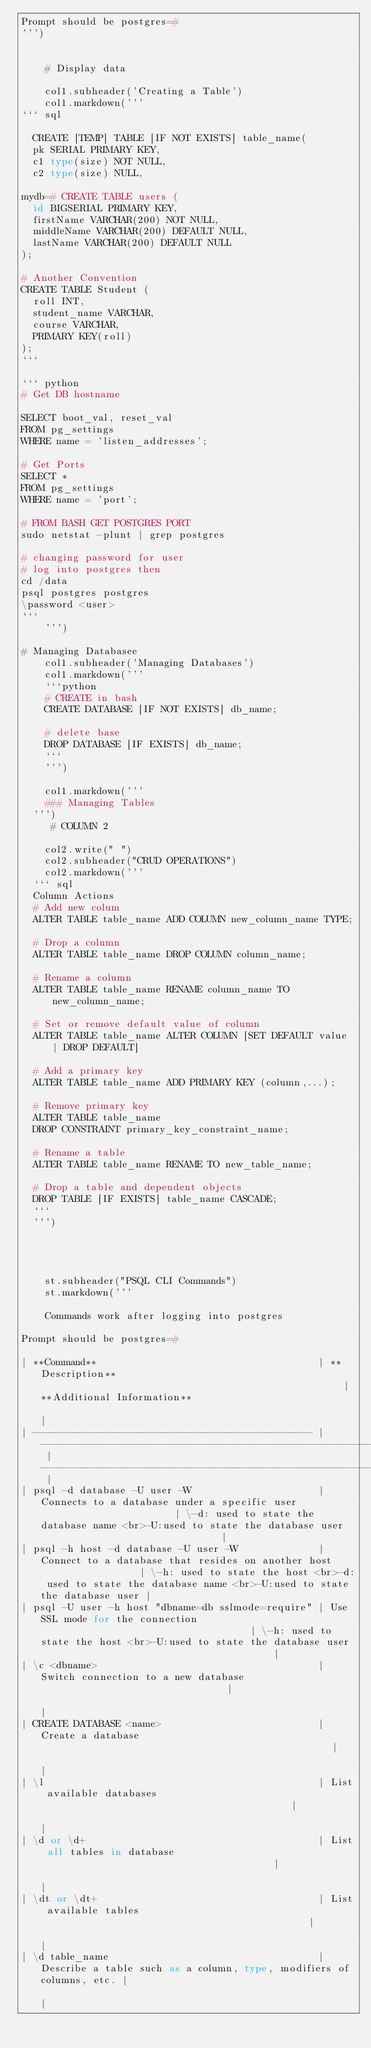<code> <loc_0><loc_0><loc_500><loc_500><_Python_>Prompt should be postgres=#
''')


    # Display data

    col1.subheader('Creating a Table')
    col1.markdown('''
``` sql

	CREATE [TEMP] TABLE [IF NOT EXISTS] table_name(
	pk SERIAL PRIMARY KEY,
	c1 type(size) NOT NULL,
	c2 type(size) NULL,

mydb=# CREATE TABLE users (
  id BIGSERIAL PRIMARY KEY,
  firstName VARCHAR(200) NOT NULL,
  middleName VARCHAR(200) DEFAULT NULL,
  lastName VARCHAR(200) DEFAULT NULL
);

# Another Convention
CREATE TABLE Student (
	roll INT,
	student_name VARCHAR,
	course VARCHAR,
	PRIMARY KEY(roll)
);
```

``` python
# Get DB hostname

SELECT boot_val, reset_val
FROM pg_settings
WHERE name = 'listen_addresses';

# Get Ports
SELECT *
FROM pg_settings
WHERE name = 'port';

# FROM BASH GET POSTGRES PORT
sudo netstat -plunt | grep postgres

# changing password for user
# log into postgres then
cd /data
psql postgres postgres
\password <user>
```
    ''')

# Managing Databasee
    col1.subheader('Managing Databases')
    col1.markdown('''
    ```python
    # CREATE in bash
    CREATE DATABASE [IF NOT EXISTS] db_name;
    
    # delete base
    DROP DATABASE [IF EXISTS] db_name;
    ```
    ''')
    
    col1.markdown('''
  	### Managing Tables	
	''')
     # COLUMN 2
    
    col2.write(" ")
    col2.subheader("CRUD OPERATIONS")
    col2.markdown('''
	``` sql
	Column Actions
	# Add new colum
	ALTER TABLE table_name ADD COLUMN new_column_name TYPE;

	# Drop a column
	ALTER TABLE table_name DROP COLUMN column_name;

	# Rename a column
	ALTER TABLE table_name RENAME column_name TO new_column_name;

	# Set or remove default value of column
	ALTER TABLE table_name ALTER COLUMN [SET DEFAULT value | DROP DEFAULT]

	# Add a primary key
	ALTER TABLE table_name ADD PRIMARY KEY (column,...);

	# Remove primary key
	ALTER TABLE table_name 
	DROP CONSTRAINT primary_key_constraint_name;

	# Rename a table
	ALTER TABLE table_name RENAME TO new_table_name;

	# Drop a table and dependent objects
	DROP TABLE [IF EXISTS] table_name CASCADE;
	```
	''')
   
 
 
 
    st.subheader("PSQL CLI Commands")
    st.markdown('''
                  
    Commands work after logging into postgres

Prompt should be postgres=#

| **Command**                                      | **Description**                                                     | **Additional Information**                                                                                 |
| ------------------------------------------------ | ------------------------------------------------------------------- | ---------------------------------------------------------------------------------------------------------- |
| psql -d database -U user -W                      | Connects to a database under a specific user                        | \-d: used to state the database name <br>-U:used to state the database user                                |
| psql -h host -d database -U user -W              | Connect to a database that resides on another host                  | \-h: used to state the host <br>-d: used to state the database name <br>-U:used to state the database user |
| psql -U user -h host "dbname=db sslmode=require" | Use SSL mode for the connection                                     | \-h: used to state the host <br>-U:used to state the database user                                         |
| \c <dbname>                                      | Switch connection to a new database                                 |                                                                                                            |
| CREATE DATABASE <name>                           | Create a database                                                   |                                                                                                            |
| \l                                               | List available databases                                            |                                                                                                            |
| \d or \d+                                        | List all tables in database                                         |                                                                                                            |
| \dt or \dt+                                      | List available tables                                               |                                                                                                            |
| \d table_name                                    | Describe a table such as a column, type, modifiers of columns, etc. |                                                                                                            |</code> 